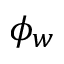<formula> <loc_0><loc_0><loc_500><loc_500>\phi _ { w }</formula> 